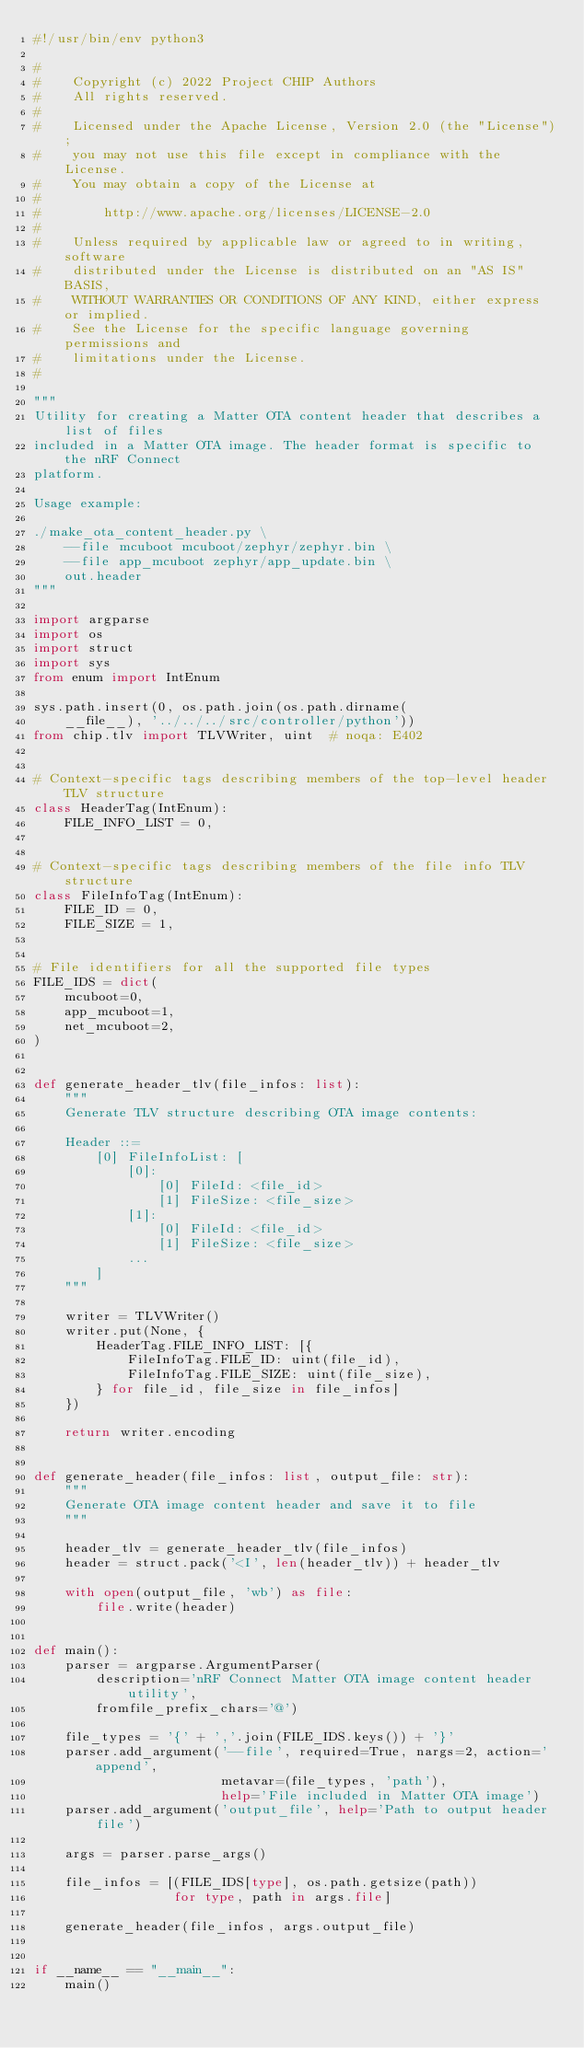Convert code to text. <code><loc_0><loc_0><loc_500><loc_500><_Python_>#!/usr/bin/env python3

#
#    Copyright (c) 2022 Project CHIP Authors
#    All rights reserved.
#
#    Licensed under the Apache License, Version 2.0 (the "License");
#    you may not use this file except in compliance with the License.
#    You may obtain a copy of the License at
#
#        http://www.apache.org/licenses/LICENSE-2.0
#
#    Unless required by applicable law or agreed to in writing, software
#    distributed under the License is distributed on an "AS IS" BASIS,
#    WITHOUT WARRANTIES OR CONDITIONS OF ANY KIND, either express or implied.
#    See the License for the specific language governing permissions and
#    limitations under the License.
#

"""
Utility for creating a Matter OTA content header that describes a list of files
included in a Matter OTA image. The header format is specific to the nRF Connect
platform.

Usage example:

./make_ota_content_header.py \
    --file mcuboot mcuboot/zephyr/zephyr.bin \
    --file app_mcuboot zephyr/app_update.bin \
    out.header
"""

import argparse
import os
import struct
import sys
from enum import IntEnum

sys.path.insert(0, os.path.join(os.path.dirname(
    __file__), '../../../src/controller/python'))
from chip.tlv import TLVWriter, uint  # noqa: E402


# Context-specific tags describing members of the top-level header TLV structure
class HeaderTag(IntEnum):
    FILE_INFO_LIST = 0,


# Context-specific tags describing members of the file info TLV structure
class FileInfoTag(IntEnum):
    FILE_ID = 0,
    FILE_SIZE = 1,


# File identifiers for all the supported file types
FILE_IDS = dict(
    mcuboot=0,
    app_mcuboot=1,
    net_mcuboot=2,
)


def generate_header_tlv(file_infos: list):
    """
    Generate TLV structure describing OTA image contents:

    Header ::=
        [0] FileInfoList: [
            [0]:
                [0] FileId: <file_id>
                [1] FileSize: <file_size>
            [1]:
                [0] FileId: <file_id>
                [1] FileSize: <file_size>
            ...
        ]
    """

    writer = TLVWriter()
    writer.put(None, {
        HeaderTag.FILE_INFO_LIST: [{
            FileInfoTag.FILE_ID: uint(file_id),
            FileInfoTag.FILE_SIZE: uint(file_size),
        } for file_id, file_size in file_infos]
    })

    return writer.encoding


def generate_header(file_infos: list, output_file: str):
    """
    Generate OTA image content header and save it to file
    """

    header_tlv = generate_header_tlv(file_infos)
    header = struct.pack('<I', len(header_tlv)) + header_tlv

    with open(output_file, 'wb') as file:
        file.write(header)


def main():
    parser = argparse.ArgumentParser(
        description='nRF Connect Matter OTA image content header utility',
        fromfile_prefix_chars='@')

    file_types = '{' + ','.join(FILE_IDS.keys()) + '}'
    parser.add_argument('--file', required=True, nargs=2, action='append',
                        metavar=(file_types, 'path'),
                        help='File included in Matter OTA image')
    parser.add_argument('output_file', help='Path to output header file')

    args = parser.parse_args()

    file_infos = [(FILE_IDS[type], os.path.getsize(path))
                  for type, path in args.file]

    generate_header(file_infos, args.output_file)


if __name__ == "__main__":
    main()
</code> 